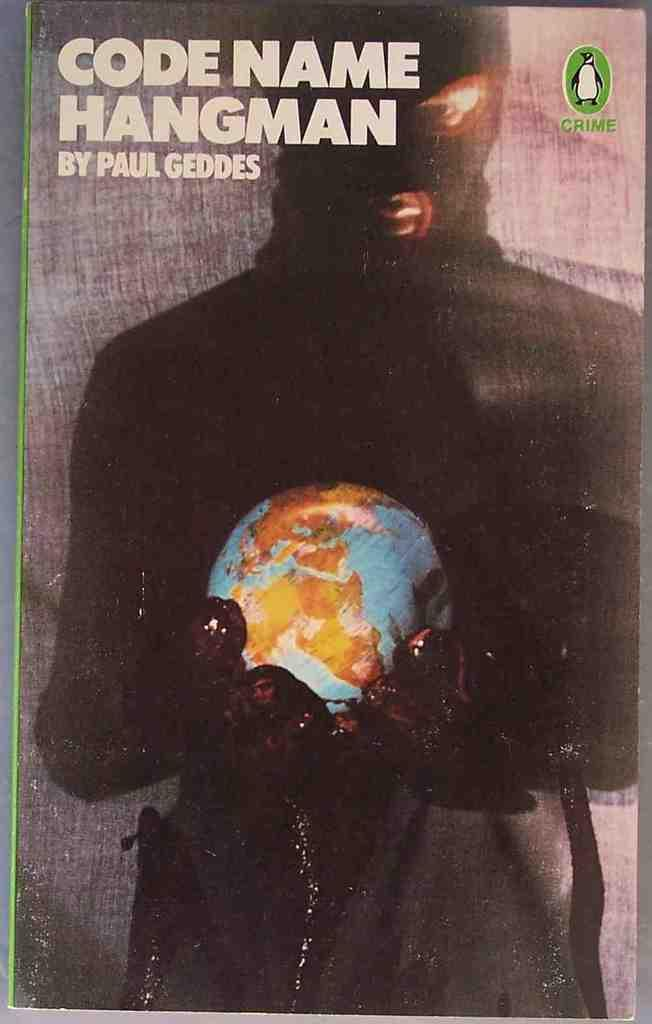<image>
Write a terse but informative summary of the picture. The cover of the book Code Name Hangman by Paul Geddes. 